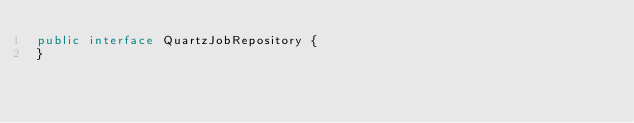<code> <loc_0><loc_0><loc_500><loc_500><_Java_>public interface QuartzJobRepository {
}
</code> 